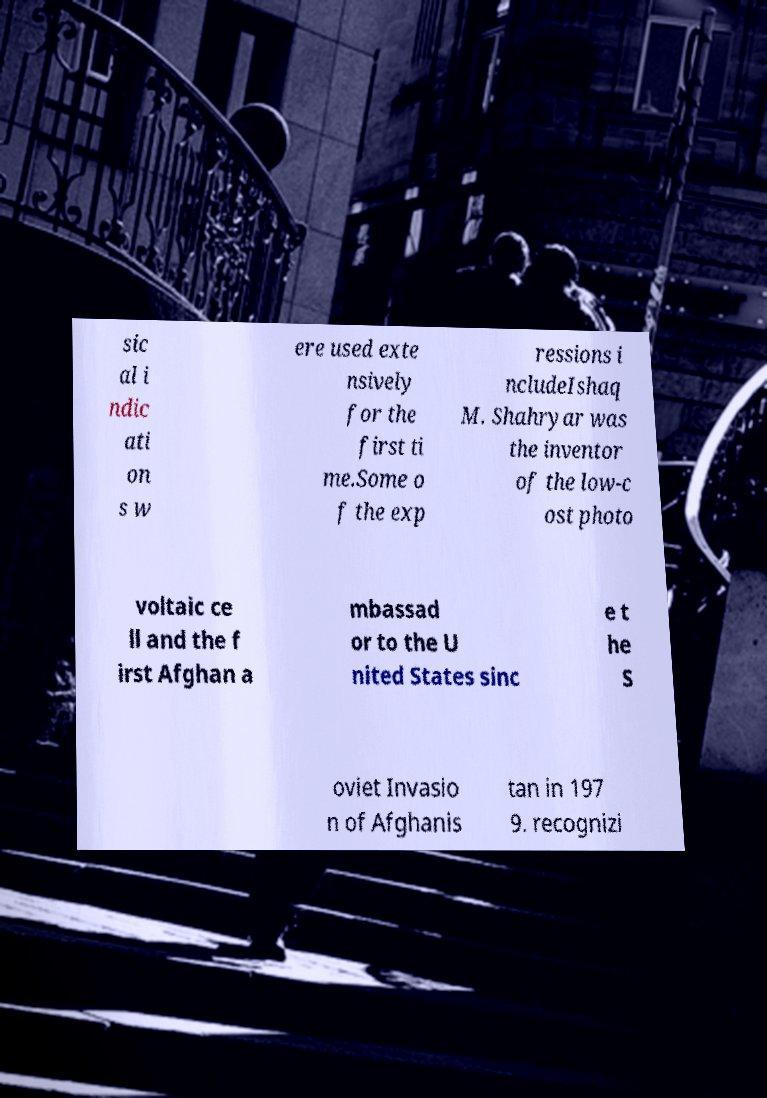Could you assist in decoding the text presented in this image and type it out clearly? sic al i ndic ati on s w ere used exte nsively for the first ti me.Some o f the exp ressions i ncludeIshaq M. Shahryar was the inventor of the low-c ost photo voltaic ce ll and the f irst Afghan a mbassad or to the U nited States sinc e t he S oviet Invasio n of Afghanis tan in 197 9. recognizi 